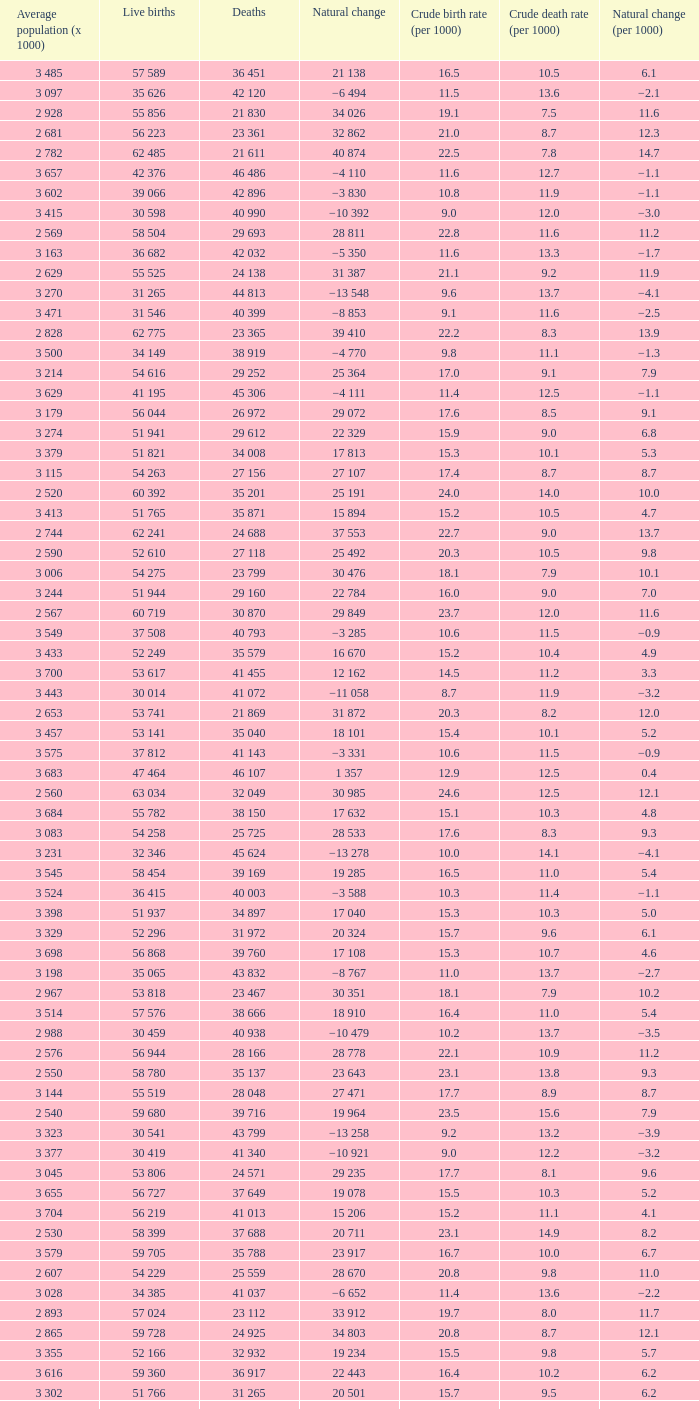Which Average population (x 1000) has a Crude death rate (per 1000) smaller than 10.9, and a Crude birth rate (per 1000) smaller than 19.7, and a Natural change (per 1000) of 8.7, and Live births of 54 263? 3 115. Could you parse the entire table? {'header': ['Average population (x 1000)', 'Live births', 'Deaths', 'Natural change', 'Crude birth rate (per 1000)', 'Crude death rate (per 1000)', 'Natural change (per 1000)'], 'rows': [['3 485', '57 589', '36 451', '21 138', '16.5', '10.5', '6.1'], ['3 097', '35 626', '42 120', '−6 494', '11.5', '13.6', '−2.1'], ['2 928', '55 856', '21 830', '34 026', '19.1', '7.5', '11.6'], ['2 681', '56 223', '23 361', '32 862', '21.0', '8.7', '12.3'], ['2 782', '62 485', '21 611', '40 874', '22.5', '7.8', '14.7'], ['3 657', '42 376', '46 486', '−4 110', '11.6', '12.7', '−1.1'], ['3 602', '39 066', '42 896', '−3 830', '10.8', '11.9', '−1.1'], ['3 415', '30 598', '40 990', '−10 392', '9.0', '12.0', '−3.0'], ['2 569', '58 504', '29 693', '28 811', '22.8', '11.6', '11.2'], ['3 163', '36 682', '42 032', '−5 350', '11.6', '13.3', '−1.7'], ['2 629', '55 525', '24 138', '31 387', '21.1', '9.2', '11.9'], ['3 270', '31 265', '44 813', '−13 548', '9.6', '13.7', '−4.1'], ['3 471', '31 546', '40 399', '−8 853', '9.1', '11.6', '−2.5'], ['2 828', '62 775', '23 365', '39 410', '22.2', '8.3', '13.9'], ['3 500', '34 149', '38 919', '−4 770', '9.8', '11.1', '−1.3'], ['3 214', '54 616', '29 252', '25 364', '17.0', '9.1', '7.9'], ['3 629', '41 195', '45 306', '−4 111', '11.4', '12.5', '−1.1'], ['3 179', '56 044', '26 972', '29 072', '17.6', '8.5', '9.1'], ['3 274', '51 941', '29 612', '22 329', '15.9', '9.0', '6.8'], ['3 379', '51 821', '34 008', '17 813', '15.3', '10.1', '5.3'], ['3 115', '54 263', '27 156', '27 107', '17.4', '8.7', '8.7'], ['2 520', '60 392', '35 201', '25 191', '24.0', '14.0', '10.0'], ['3 413', '51 765', '35 871', '15 894', '15.2', '10.5', '4.7'], ['2 744', '62 241', '24 688', '37 553', '22.7', '9.0', '13.7'], ['2 590', '52 610', '27 118', '25 492', '20.3', '10.5', '9.8'], ['3 006', '54 275', '23 799', '30 476', '18.1', '7.9', '10.1'], ['3 244', '51 944', '29 160', '22 784', '16.0', '9.0', '7.0'], ['2 567', '60 719', '30 870', '29 849', '23.7', '12.0', '11.6'], ['3 549', '37 508', '40 793', '−3 285', '10.6', '11.5', '−0.9'], ['3 433', '52 249', '35 579', '16 670', '15.2', '10.4', '4.9'], ['3 700', '53 617', '41 455', '12 162', '14.5', '11.2', '3.3'], ['3 443', '30 014', '41 072', '−11 058', '8.7', '11.9', '−3.2'], ['2 653', '53 741', '21 869', '31 872', '20.3', '8.2', '12.0'], ['3 457', '53 141', '35 040', '18 101', '15.4', '10.1', '5.2'], ['3 575', '37 812', '41 143', '−3 331', '10.6', '11.5', '−0.9'], ['3 683', '47 464', '46 107', '1 357', '12.9', '12.5', '0.4'], ['2 560', '63 034', '32 049', '30 985', '24.6', '12.5', '12.1'], ['3 684', '55 782', '38 150', '17 632', '15.1', '10.3', '4.8'], ['3 083', '54 258', '25 725', '28 533', '17.6', '8.3', '9.3'], ['3 231', '32 346', '45 624', '−13 278', '10.0', '14.1', '−4.1'], ['3 545', '58 454', '39 169', '19 285', '16.5', '11.0', '5.4'], ['3 524', '36 415', '40 003', '−3 588', '10.3', '11.4', '−1.1'], ['3 398', '51 937', '34 897', '17 040', '15.3', '10.3', '5.0'], ['3 329', '52 296', '31 972', '20 324', '15.7', '9.6', '6.1'], ['3 698', '56 868', '39 760', '17 108', '15.3', '10.7', '4.6'], ['3 198', '35 065', '43 832', '−8 767', '11.0', '13.7', '−2.7'], ['2 967', '53 818', '23 467', '30 351', '18.1', '7.9', '10.2'], ['3 514', '57 576', '38 666', '18 910', '16.4', '11.0', '5.4'], ['2 988', '30 459', '40 938', '−10 479', '10.2', '13.7', '−3.5'], ['2 576', '56 944', '28 166', '28 778', '22.1', '10.9', '11.2'], ['2 550', '58 780', '35 137', '23 643', '23.1', '13.8', '9.3'], ['3 144', '55 519', '28 048', '27 471', '17.7', '8.9', '8.7'], ['2 540', '59 680', '39 716', '19 964', '23.5', '15.6', '7.9'], ['3 323', '30 541', '43 799', '−13 258', '9.2', '13.2', '−3.9'], ['3 377', '30 419', '41 340', '−10 921', '9.0', '12.2', '−3.2'], ['3 045', '53 806', '24 571', '29 235', '17.7', '8.1', '9.6'], ['3 655', '56 727', '37 649', '19 078', '15.5', '10.3', '5.2'], ['3 704', '56 219', '41 013', '15 206', '15.2', '11.1', '4.1'], ['2 530', '58 399', '37 688', '20 711', '23.1', '14.9', '8.2'], ['3 579', '59 705', '35 788', '23 917', '16.7', '10.0', '6.7'], ['2 607', '54 229', '25 559', '28 670', '20.8', '9.8', '11.0'], ['3 028', '34 385', '41 037', '−6 652', '11.4', '13.6', '−2.2'], ['2 893', '57 024', '23 112', '33 912', '19.7', '8.0', '11.7'], ['2 865', '59 728', '24 925', '34 803', '20.8', '8.7', '12.1'], ['3 355', '52 166', '32 932', '19 234', '15.5', '9.8', '5.7'], ['3 616', '59 360', '36 917', '22 443', '16.4', '10.2', '6.2'], ['3 302', '51 766', '31 265', '20 501', '15.7', '9.5', '6.2'], ['2 711', '61 190', '22 103', '39 087', '22.6', '8.2', '14.4']]} 